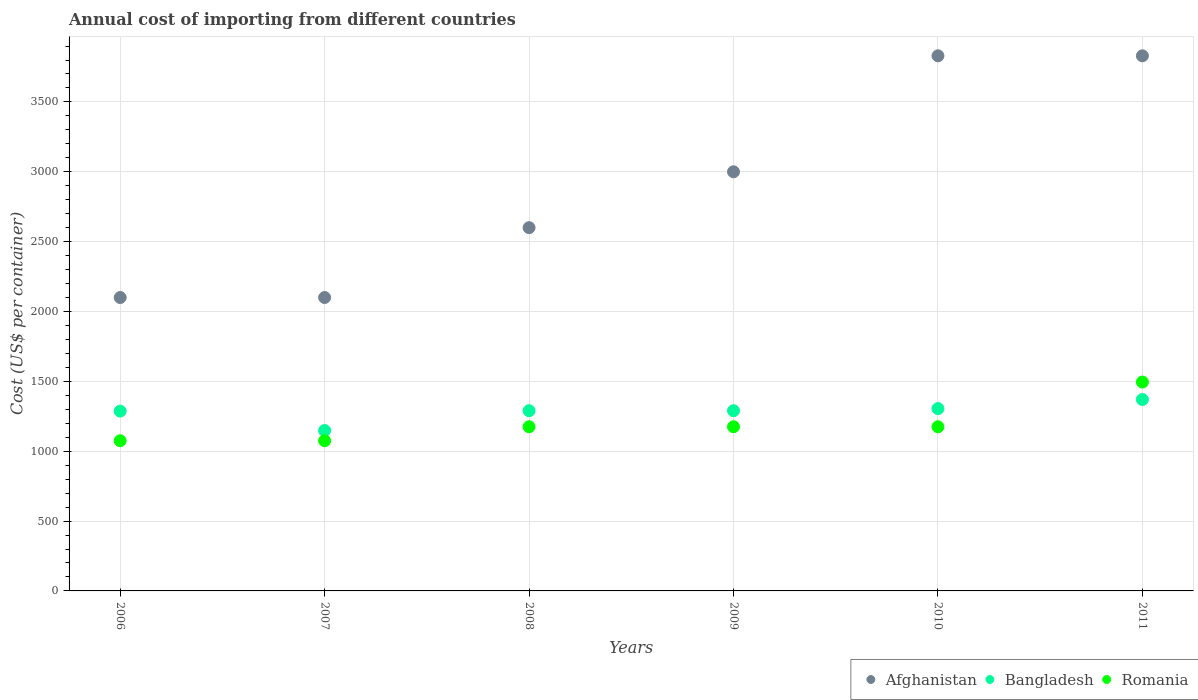How many different coloured dotlines are there?
Offer a very short reply. 3. What is the total annual cost of importing in Bangladesh in 2009?
Your answer should be very brief. 1290. Across all years, what is the maximum total annual cost of importing in Afghanistan?
Your response must be concise. 3830. Across all years, what is the minimum total annual cost of importing in Bangladesh?
Offer a terse response. 1148. What is the total total annual cost of importing in Afghanistan in the graph?
Your answer should be very brief. 1.75e+04. What is the difference between the total annual cost of importing in Afghanistan in 2008 and the total annual cost of importing in Romania in 2009?
Make the answer very short. 1425. What is the average total annual cost of importing in Bangladesh per year?
Your response must be concise. 1281.67. In the year 2009, what is the difference between the total annual cost of importing in Romania and total annual cost of importing in Bangladesh?
Ensure brevity in your answer.  -115. In how many years, is the total annual cost of importing in Bangladesh greater than 1900 US$?
Provide a succinct answer. 0. What is the ratio of the total annual cost of importing in Bangladesh in 2006 to that in 2010?
Keep it short and to the point. 0.99. What is the difference between the highest and the second highest total annual cost of importing in Romania?
Make the answer very short. 320. What is the difference between the highest and the lowest total annual cost of importing in Romania?
Ensure brevity in your answer.  420. Does the total annual cost of importing in Bangladesh monotonically increase over the years?
Offer a terse response. No. Is the total annual cost of importing in Bangladesh strictly greater than the total annual cost of importing in Afghanistan over the years?
Make the answer very short. No. Is the total annual cost of importing in Bangladesh strictly less than the total annual cost of importing in Afghanistan over the years?
Give a very brief answer. Yes. How many dotlines are there?
Offer a very short reply. 3. How many years are there in the graph?
Offer a very short reply. 6. What is the difference between two consecutive major ticks on the Y-axis?
Make the answer very short. 500. Are the values on the major ticks of Y-axis written in scientific E-notation?
Offer a very short reply. No. Does the graph contain any zero values?
Provide a short and direct response. No. Where does the legend appear in the graph?
Your response must be concise. Bottom right. What is the title of the graph?
Offer a very short reply. Annual cost of importing from different countries. What is the label or title of the X-axis?
Your answer should be very brief. Years. What is the label or title of the Y-axis?
Offer a very short reply. Cost (US$ per container). What is the Cost (US$ per container) of Afghanistan in 2006?
Provide a short and direct response. 2100. What is the Cost (US$ per container) of Bangladesh in 2006?
Your answer should be compact. 1287. What is the Cost (US$ per container) of Romania in 2006?
Offer a very short reply. 1075. What is the Cost (US$ per container) in Afghanistan in 2007?
Keep it short and to the point. 2100. What is the Cost (US$ per container) in Bangladesh in 2007?
Keep it short and to the point. 1148. What is the Cost (US$ per container) of Romania in 2007?
Offer a terse response. 1075. What is the Cost (US$ per container) in Afghanistan in 2008?
Provide a short and direct response. 2600. What is the Cost (US$ per container) in Bangladesh in 2008?
Your answer should be very brief. 1290. What is the Cost (US$ per container) of Romania in 2008?
Provide a short and direct response. 1175. What is the Cost (US$ per container) of Afghanistan in 2009?
Your answer should be very brief. 3000. What is the Cost (US$ per container) in Bangladesh in 2009?
Your answer should be compact. 1290. What is the Cost (US$ per container) in Romania in 2009?
Provide a short and direct response. 1175. What is the Cost (US$ per container) in Afghanistan in 2010?
Provide a short and direct response. 3830. What is the Cost (US$ per container) of Bangladesh in 2010?
Ensure brevity in your answer.  1305. What is the Cost (US$ per container) in Romania in 2010?
Give a very brief answer. 1175. What is the Cost (US$ per container) in Afghanistan in 2011?
Keep it short and to the point. 3830. What is the Cost (US$ per container) of Bangladesh in 2011?
Offer a very short reply. 1370. What is the Cost (US$ per container) in Romania in 2011?
Your answer should be very brief. 1495. Across all years, what is the maximum Cost (US$ per container) of Afghanistan?
Offer a very short reply. 3830. Across all years, what is the maximum Cost (US$ per container) of Bangladesh?
Your answer should be compact. 1370. Across all years, what is the maximum Cost (US$ per container) of Romania?
Offer a very short reply. 1495. Across all years, what is the minimum Cost (US$ per container) in Afghanistan?
Your response must be concise. 2100. Across all years, what is the minimum Cost (US$ per container) in Bangladesh?
Make the answer very short. 1148. Across all years, what is the minimum Cost (US$ per container) in Romania?
Your response must be concise. 1075. What is the total Cost (US$ per container) in Afghanistan in the graph?
Provide a succinct answer. 1.75e+04. What is the total Cost (US$ per container) of Bangladesh in the graph?
Provide a succinct answer. 7690. What is the total Cost (US$ per container) in Romania in the graph?
Offer a very short reply. 7170. What is the difference between the Cost (US$ per container) in Bangladesh in 2006 and that in 2007?
Provide a succinct answer. 139. What is the difference between the Cost (US$ per container) in Afghanistan in 2006 and that in 2008?
Offer a very short reply. -500. What is the difference between the Cost (US$ per container) in Bangladesh in 2006 and that in 2008?
Offer a very short reply. -3. What is the difference between the Cost (US$ per container) of Romania in 2006 and that in 2008?
Provide a succinct answer. -100. What is the difference between the Cost (US$ per container) of Afghanistan in 2006 and that in 2009?
Your answer should be very brief. -900. What is the difference between the Cost (US$ per container) of Bangladesh in 2006 and that in 2009?
Your response must be concise. -3. What is the difference between the Cost (US$ per container) in Romania in 2006 and that in 2009?
Make the answer very short. -100. What is the difference between the Cost (US$ per container) in Afghanistan in 2006 and that in 2010?
Provide a succinct answer. -1730. What is the difference between the Cost (US$ per container) in Bangladesh in 2006 and that in 2010?
Your response must be concise. -18. What is the difference between the Cost (US$ per container) in Romania in 2006 and that in 2010?
Your answer should be very brief. -100. What is the difference between the Cost (US$ per container) of Afghanistan in 2006 and that in 2011?
Keep it short and to the point. -1730. What is the difference between the Cost (US$ per container) of Bangladesh in 2006 and that in 2011?
Provide a short and direct response. -83. What is the difference between the Cost (US$ per container) in Romania in 2006 and that in 2011?
Ensure brevity in your answer.  -420. What is the difference between the Cost (US$ per container) of Afghanistan in 2007 and that in 2008?
Offer a terse response. -500. What is the difference between the Cost (US$ per container) of Bangladesh in 2007 and that in 2008?
Provide a succinct answer. -142. What is the difference between the Cost (US$ per container) of Romania in 2007 and that in 2008?
Provide a succinct answer. -100. What is the difference between the Cost (US$ per container) of Afghanistan in 2007 and that in 2009?
Ensure brevity in your answer.  -900. What is the difference between the Cost (US$ per container) of Bangladesh in 2007 and that in 2009?
Provide a succinct answer. -142. What is the difference between the Cost (US$ per container) in Romania in 2007 and that in 2009?
Your answer should be very brief. -100. What is the difference between the Cost (US$ per container) of Afghanistan in 2007 and that in 2010?
Offer a terse response. -1730. What is the difference between the Cost (US$ per container) in Bangladesh in 2007 and that in 2010?
Provide a succinct answer. -157. What is the difference between the Cost (US$ per container) in Romania in 2007 and that in 2010?
Your response must be concise. -100. What is the difference between the Cost (US$ per container) of Afghanistan in 2007 and that in 2011?
Give a very brief answer. -1730. What is the difference between the Cost (US$ per container) of Bangladesh in 2007 and that in 2011?
Your answer should be compact. -222. What is the difference between the Cost (US$ per container) of Romania in 2007 and that in 2011?
Your answer should be very brief. -420. What is the difference between the Cost (US$ per container) of Afghanistan in 2008 and that in 2009?
Your answer should be compact. -400. What is the difference between the Cost (US$ per container) of Bangladesh in 2008 and that in 2009?
Provide a succinct answer. 0. What is the difference between the Cost (US$ per container) of Afghanistan in 2008 and that in 2010?
Give a very brief answer. -1230. What is the difference between the Cost (US$ per container) of Romania in 2008 and that in 2010?
Give a very brief answer. 0. What is the difference between the Cost (US$ per container) of Afghanistan in 2008 and that in 2011?
Offer a terse response. -1230. What is the difference between the Cost (US$ per container) in Bangladesh in 2008 and that in 2011?
Ensure brevity in your answer.  -80. What is the difference between the Cost (US$ per container) in Romania in 2008 and that in 2011?
Your answer should be compact. -320. What is the difference between the Cost (US$ per container) of Afghanistan in 2009 and that in 2010?
Offer a very short reply. -830. What is the difference between the Cost (US$ per container) of Afghanistan in 2009 and that in 2011?
Make the answer very short. -830. What is the difference between the Cost (US$ per container) in Bangladesh in 2009 and that in 2011?
Offer a terse response. -80. What is the difference between the Cost (US$ per container) in Romania in 2009 and that in 2011?
Keep it short and to the point. -320. What is the difference between the Cost (US$ per container) of Bangladesh in 2010 and that in 2011?
Provide a succinct answer. -65. What is the difference between the Cost (US$ per container) of Romania in 2010 and that in 2011?
Offer a very short reply. -320. What is the difference between the Cost (US$ per container) of Afghanistan in 2006 and the Cost (US$ per container) of Bangladesh in 2007?
Offer a terse response. 952. What is the difference between the Cost (US$ per container) of Afghanistan in 2006 and the Cost (US$ per container) of Romania in 2007?
Your answer should be very brief. 1025. What is the difference between the Cost (US$ per container) of Bangladesh in 2006 and the Cost (US$ per container) of Romania in 2007?
Offer a terse response. 212. What is the difference between the Cost (US$ per container) in Afghanistan in 2006 and the Cost (US$ per container) in Bangladesh in 2008?
Ensure brevity in your answer.  810. What is the difference between the Cost (US$ per container) in Afghanistan in 2006 and the Cost (US$ per container) in Romania in 2008?
Ensure brevity in your answer.  925. What is the difference between the Cost (US$ per container) of Bangladesh in 2006 and the Cost (US$ per container) of Romania in 2008?
Ensure brevity in your answer.  112. What is the difference between the Cost (US$ per container) in Afghanistan in 2006 and the Cost (US$ per container) in Bangladesh in 2009?
Your answer should be very brief. 810. What is the difference between the Cost (US$ per container) of Afghanistan in 2006 and the Cost (US$ per container) of Romania in 2009?
Provide a short and direct response. 925. What is the difference between the Cost (US$ per container) in Bangladesh in 2006 and the Cost (US$ per container) in Romania in 2009?
Provide a succinct answer. 112. What is the difference between the Cost (US$ per container) of Afghanistan in 2006 and the Cost (US$ per container) of Bangladesh in 2010?
Provide a succinct answer. 795. What is the difference between the Cost (US$ per container) in Afghanistan in 2006 and the Cost (US$ per container) in Romania in 2010?
Keep it short and to the point. 925. What is the difference between the Cost (US$ per container) of Bangladesh in 2006 and the Cost (US$ per container) of Romania in 2010?
Make the answer very short. 112. What is the difference between the Cost (US$ per container) of Afghanistan in 2006 and the Cost (US$ per container) of Bangladesh in 2011?
Your answer should be very brief. 730. What is the difference between the Cost (US$ per container) in Afghanistan in 2006 and the Cost (US$ per container) in Romania in 2011?
Provide a succinct answer. 605. What is the difference between the Cost (US$ per container) in Bangladesh in 2006 and the Cost (US$ per container) in Romania in 2011?
Give a very brief answer. -208. What is the difference between the Cost (US$ per container) of Afghanistan in 2007 and the Cost (US$ per container) of Bangladesh in 2008?
Give a very brief answer. 810. What is the difference between the Cost (US$ per container) in Afghanistan in 2007 and the Cost (US$ per container) in Romania in 2008?
Give a very brief answer. 925. What is the difference between the Cost (US$ per container) in Afghanistan in 2007 and the Cost (US$ per container) in Bangladesh in 2009?
Give a very brief answer. 810. What is the difference between the Cost (US$ per container) in Afghanistan in 2007 and the Cost (US$ per container) in Romania in 2009?
Provide a succinct answer. 925. What is the difference between the Cost (US$ per container) of Afghanistan in 2007 and the Cost (US$ per container) of Bangladesh in 2010?
Make the answer very short. 795. What is the difference between the Cost (US$ per container) of Afghanistan in 2007 and the Cost (US$ per container) of Romania in 2010?
Offer a terse response. 925. What is the difference between the Cost (US$ per container) in Bangladesh in 2007 and the Cost (US$ per container) in Romania in 2010?
Provide a short and direct response. -27. What is the difference between the Cost (US$ per container) in Afghanistan in 2007 and the Cost (US$ per container) in Bangladesh in 2011?
Offer a terse response. 730. What is the difference between the Cost (US$ per container) of Afghanistan in 2007 and the Cost (US$ per container) of Romania in 2011?
Keep it short and to the point. 605. What is the difference between the Cost (US$ per container) in Bangladesh in 2007 and the Cost (US$ per container) in Romania in 2011?
Keep it short and to the point. -347. What is the difference between the Cost (US$ per container) in Afghanistan in 2008 and the Cost (US$ per container) in Bangladesh in 2009?
Provide a succinct answer. 1310. What is the difference between the Cost (US$ per container) in Afghanistan in 2008 and the Cost (US$ per container) in Romania in 2009?
Offer a terse response. 1425. What is the difference between the Cost (US$ per container) in Bangladesh in 2008 and the Cost (US$ per container) in Romania in 2009?
Your response must be concise. 115. What is the difference between the Cost (US$ per container) of Afghanistan in 2008 and the Cost (US$ per container) of Bangladesh in 2010?
Your answer should be compact. 1295. What is the difference between the Cost (US$ per container) of Afghanistan in 2008 and the Cost (US$ per container) of Romania in 2010?
Keep it short and to the point. 1425. What is the difference between the Cost (US$ per container) of Bangladesh in 2008 and the Cost (US$ per container) of Romania in 2010?
Give a very brief answer. 115. What is the difference between the Cost (US$ per container) of Afghanistan in 2008 and the Cost (US$ per container) of Bangladesh in 2011?
Make the answer very short. 1230. What is the difference between the Cost (US$ per container) in Afghanistan in 2008 and the Cost (US$ per container) in Romania in 2011?
Ensure brevity in your answer.  1105. What is the difference between the Cost (US$ per container) in Bangladesh in 2008 and the Cost (US$ per container) in Romania in 2011?
Ensure brevity in your answer.  -205. What is the difference between the Cost (US$ per container) of Afghanistan in 2009 and the Cost (US$ per container) of Bangladesh in 2010?
Provide a succinct answer. 1695. What is the difference between the Cost (US$ per container) of Afghanistan in 2009 and the Cost (US$ per container) of Romania in 2010?
Your response must be concise. 1825. What is the difference between the Cost (US$ per container) of Bangladesh in 2009 and the Cost (US$ per container) of Romania in 2010?
Make the answer very short. 115. What is the difference between the Cost (US$ per container) in Afghanistan in 2009 and the Cost (US$ per container) in Bangladesh in 2011?
Your answer should be very brief. 1630. What is the difference between the Cost (US$ per container) in Afghanistan in 2009 and the Cost (US$ per container) in Romania in 2011?
Provide a short and direct response. 1505. What is the difference between the Cost (US$ per container) of Bangladesh in 2009 and the Cost (US$ per container) of Romania in 2011?
Make the answer very short. -205. What is the difference between the Cost (US$ per container) of Afghanistan in 2010 and the Cost (US$ per container) of Bangladesh in 2011?
Keep it short and to the point. 2460. What is the difference between the Cost (US$ per container) of Afghanistan in 2010 and the Cost (US$ per container) of Romania in 2011?
Your response must be concise. 2335. What is the difference between the Cost (US$ per container) in Bangladesh in 2010 and the Cost (US$ per container) in Romania in 2011?
Your answer should be very brief. -190. What is the average Cost (US$ per container) in Afghanistan per year?
Ensure brevity in your answer.  2910. What is the average Cost (US$ per container) in Bangladesh per year?
Give a very brief answer. 1281.67. What is the average Cost (US$ per container) of Romania per year?
Make the answer very short. 1195. In the year 2006, what is the difference between the Cost (US$ per container) in Afghanistan and Cost (US$ per container) in Bangladesh?
Make the answer very short. 813. In the year 2006, what is the difference between the Cost (US$ per container) in Afghanistan and Cost (US$ per container) in Romania?
Your answer should be very brief. 1025. In the year 2006, what is the difference between the Cost (US$ per container) in Bangladesh and Cost (US$ per container) in Romania?
Ensure brevity in your answer.  212. In the year 2007, what is the difference between the Cost (US$ per container) in Afghanistan and Cost (US$ per container) in Bangladesh?
Provide a succinct answer. 952. In the year 2007, what is the difference between the Cost (US$ per container) of Afghanistan and Cost (US$ per container) of Romania?
Provide a succinct answer. 1025. In the year 2008, what is the difference between the Cost (US$ per container) in Afghanistan and Cost (US$ per container) in Bangladesh?
Provide a short and direct response. 1310. In the year 2008, what is the difference between the Cost (US$ per container) in Afghanistan and Cost (US$ per container) in Romania?
Offer a very short reply. 1425. In the year 2008, what is the difference between the Cost (US$ per container) of Bangladesh and Cost (US$ per container) of Romania?
Ensure brevity in your answer.  115. In the year 2009, what is the difference between the Cost (US$ per container) of Afghanistan and Cost (US$ per container) of Bangladesh?
Keep it short and to the point. 1710. In the year 2009, what is the difference between the Cost (US$ per container) in Afghanistan and Cost (US$ per container) in Romania?
Provide a short and direct response. 1825. In the year 2009, what is the difference between the Cost (US$ per container) of Bangladesh and Cost (US$ per container) of Romania?
Offer a very short reply. 115. In the year 2010, what is the difference between the Cost (US$ per container) in Afghanistan and Cost (US$ per container) in Bangladesh?
Provide a short and direct response. 2525. In the year 2010, what is the difference between the Cost (US$ per container) of Afghanistan and Cost (US$ per container) of Romania?
Your response must be concise. 2655. In the year 2010, what is the difference between the Cost (US$ per container) in Bangladesh and Cost (US$ per container) in Romania?
Your response must be concise. 130. In the year 2011, what is the difference between the Cost (US$ per container) of Afghanistan and Cost (US$ per container) of Bangladesh?
Keep it short and to the point. 2460. In the year 2011, what is the difference between the Cost (US$ per container) of Afghanistan and Cost (US$ per container) of Romania?
Your answer should be very brief. 2335. In the year 2011, what is the difference between the Cost (US$ per container) in Bangladesh and Cost (US$ per container) in Romania?
Provide a short and direct response. -125. What is the ratio of the Cost (US$ per container) in Bangladesh in 2006 to that in 2007?
Make the answer very short. 1.12. What is the ratio of the Cost (US$ per container) of Romania in 2006 to that in 2007?
Provide a succinct answer. 1. What is the ratio of the Cost (US$ per container) in Afghanistan in 2006 to that in 2008?
Offer a terse response. 0.81. What is the ratio of the Cost (US$ per container) in Bangladesh in 2006 to that in 2008?
Provide a short and direct response. 1. What is the ratio of the Cost (US$ per container) of Romania in 2006 to that in 2008?
Provide a succinct answer. 0.91. What is the ratio of the Cost (US$ per container) of Afghanistan in 2006 to that in 2009?
Provide a succinct answer. 0.7. What is the ratio of the Cost (US$ per container) of Bangladesh in 2006 to that in 2009?
Give a very brief answer. 1. What is the ratio of the Cost (US$ per container) in Romania in 2006 to that in 2009?
Ensure brevity in your answer.  0.91. What is the ratio of the Cost (US$ per container) in Afghanistan in 2006 to that in 2010?
Make the answer very short. 0.55. What is the ratio of the Cost (US$ per container) in Bangladesh in 2006 to that in 2010?
Your answer should be very brief. 0.99. What is the ratio of the Cost (US$ per container) in Romania in 2006 to that in 2010?
Give a very brief answer. 0.91. What is the ratio of the Cost (US$ per container) of Afghanistan in 2006 to that in 2011?
Ensure brevity in your answer.  0.55. What is the ratio of the Cost (US$ per container) of Bangladesh in 2006 to that in 2011?
Offer a terse response. 0.94. What is the ratio of the Cost (US$ per container) of Romania in 2006 to that in 2011?
Provide a succinct answer. 0.72. What is the ratio of the Cost (US$ per container) in Afghanistan in 2007 to that in 2008?
Provide a short and direct response. 0.81. What is the ratio of the Cost (US$ per container) of Bangladesh in 2007 to that in 2008?
Offer a terse response. 0.89. What is the ratio of the Cost (US$ per container) of Romania in 2007 to that in 2008?
Offer a very short reply. 0.91. What is the ratio of the Cost (US$ per container) in Bangladesh in 2007 to that in 2009?
Offer a very short reply. 0.89. What is the ratio of the Cost (US$ per container) of Romania in 2007 to that in 2009?
Keep it short and to the point. 0.91. What is the ratio of the Cost (US$ per container) in Afghanistan in 2007 to that in 2010?
Your answer should be very brief. 0.55. What is the ratio of the Cost (US$ per container) in Bangladesh in 2007 to that in 2010?
Offer a terse response. 0.88. What is the ratio of the Cost (US$ per container) in Romania in 2007 to that in 2010?
Provide a short and direct response. 0.91. What is the ratio of the Cost (US$ per container) in Afghanistan in 2007 to that in 2011?
Offer a terse response. 0.55. What is the ratio of the Cost (US$ per container) in Bangladesh in 2007 to that in 2011?
Keep it short and to the point. 0.84. What is the ratio of the Cost (US$ per container) of Romania in 2007 to that in 2011?
Offer a terse response. 0.72. What is the ratio of the Cost (US$ per container) in Afghanistan in 2008 to that in 2009?
Give a very brief answer. 0.87. What is the ratio of the Cost (US$ per container) of Romania in 2008 to that in 2009?
Offer a very short reply. 1. What is the ratio of the Cost (US$ per container) in Afghanistan in 2008 to that in 2010?
Provide a succinct answer. 0.68. What is the ratio of the Cost (US$ per container) in Bangladesh in 2008 to that in 2010?
Offer a very short reply. 0.99. What is the ratio of the Cost (US$ per container) in Romania in 2008 to that in 2010?
Your response must be concise. 1. What is the ratio of the Cost (US$ per container) in Afghanistan in 2008 to that in 2011?
Keep it short and to the point. 0.68. What is the ratio of the Cost (US$ per container) of Bangladesh in 2008 to that in 2011?
Your answer should be compact. 0.94. What is the ratio of the Cost (US$ per container) of Romania in 2008 to that in 2011?
Ensure brevity in your answer.  0.79. What is the ratio of the Cost (US$ per container) of Afghanistan in 2009 to that in 2010?
Offer a terse response. 0.78. What is the ratio of the Cost (US$ per container) in Afghanistan in 2009 to that in 2011?
Your answer should be very brief. 0.78. What is the ratio of the Cost (US$ per container) of Bangladesh in 2009 to that in 2011?
Offer a terse response. 0.94. What is the ratio of the Cost (US$ per container) of Romania in 2009 to that in 2011?
Your answer should be very brief. 0.79. What is the ratio of the Cost (US$ per container) of Afghanistan in 2010 to that in 2011?
Provide a short and direct response. 1. What is the ratio of the Cost (US$ per container) of Bangladesh in 2010 to that in 2011?
Offer a very short reply. 0.95. What is the ratio of the Cost (US$ per container) in Romania in 2010 to that in 2011?
Your answer should be very brief. 0.79. What is the difference between the highest and the second highest Cost (US$ per container) in Afghanistan?
Provide a short and direct response. 0. What is the difference between the highest and the second highest Cost (US$ per container) of Bangladesh?
Your answer should be compact. 65. What is the difference between the highest and the second highest Cost (US$ per container) of Romania?
Your answer should be very brief. 320. What is the difference between the highest and the lowest Cost (US$ per container) of Afghanistan?
Provide a short and direct response. 1730. What is the difference between the highest and the lowest Cost (US$ per container) in Bangladesh?
Provide a succinct answer. 222. What is the difference between the highest and the lowest Cost (US$ per container) of Romania?
Provide a short and direct response. 420. 